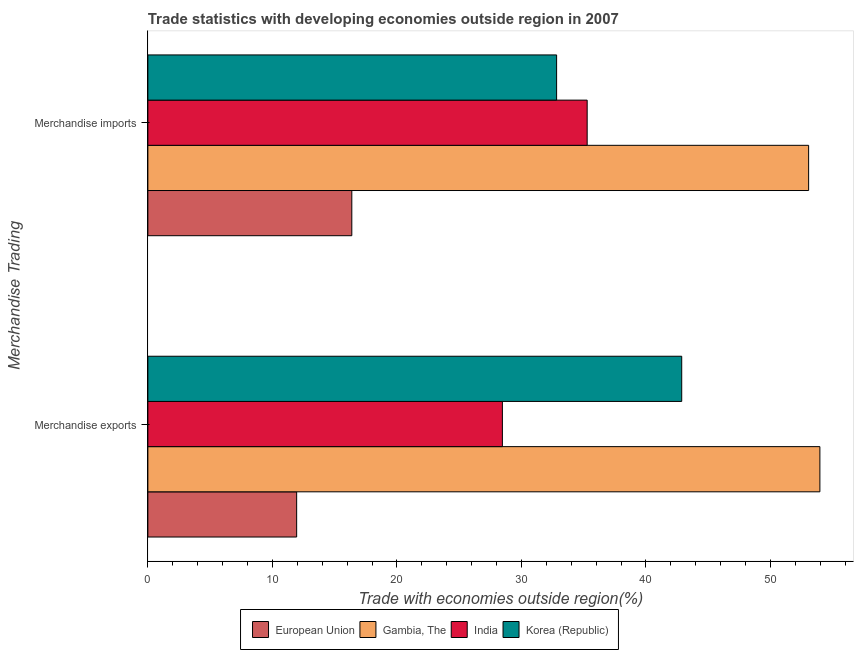How many groups of bars are there?
Offer a terse response. 2. How many bars are there on the 2nd tick from the top?
Provide a short and direct response. 4. How many bars are there on the 1st tick from the bottom?
Offer a terse response. 4. What is the label of the 1st group of bars from the top?
Your answer should be compact. Merchandise imports. What is the merchandise exports in European Union?
Provide a short and direct response. 11.95. Across all countries, what is the maximum merchandise exports?
Keep it short and to the point. 53.97. Across all countries, what is the minimum merchandise imports?
Provide a succinct answer. 16.38. In which country was the merchandise imports maximum?
Ensure brevity in your answer.  Gambia, The. In which country was the merchandise exports minimum?
Ensure brevity in your answer.  European Union. What is the total merchandise exports in the graph?
Your answer should be compact. 137.26. What is the difference between the merchandise exports in European Union and that in India?
Make the answer very short. -16.52. What is the difference between the merchandise exports in India and the merchandise imports in Gambia, The?
Make the answer very short. -24.59. What is the average merchandise imports per country?
Provide a short and direct response. 34.39. What is the difference between the merchandise imports and merchandise exports in Gambia, The?
Offer a very short reply. -0.9. What is the ratio of the merchandise exports in India to that in Korea (Republic)?
Offer a terse response. 0.66. In how many countries, is the merchandise imports greater than the average merchandise imports taken over all countries?
Keep it short and to the point. 2. What does the 3rd bar from the top in Merchandise imports represents?
Make the answer very short. Gambia, The. How many bars are there?
Ensure brevity in your answer.  8. Are all the bars in the graph horizontal?
Keep it short and to the point. Yes. What is the difference between two consecutive major ticks on the X-axis?
Give a very brief answer. 10. Does the graph contain any zero values?
Keep it short and to the point. No. Where does the legend appear in the graph?
Keep it short and to the point. Bottom center. What is the title of the graph?
Keep it short and to the point. Trade statistics with developing economies outside region in 2007. Does "Benin" appear as one of the legend labels in the graph?
Your answer should be compact. No. What is the label or title of the X-axis?
Make the answer very short. Trade with economies outside region(%). What is the label or title of the Y-axis?
Your answer should be very brief. Merchandise Trading. What is the Trade with economies outside region(%) of European Union in Merchandise exports?
Make the answer very short. 11.95. What is the Trade with economies outside region(%) of Gambia, The in Merchandise exports?
Ensure brevity in your answer.  53.97. What is the Trade with economies outside region(%) of India in Merchandise exports?
Provide a succinct answer. 28.47. What is the Trade with economies outside region(%) of Korea (Republic) in Merchandise exports?
Ensure brevity in your answer.  42.87. What is the Trade with economies outside region(%) in European Union in Merchandise imports?
Make the answer very short. 16.38. What is the Trade with economies outside region(%) in Gambia, The in Merchandise imports?
Your answer should be very brief. 53.06. What is the Trade with economies outside region(%) of India in Merchandise imports?
Keep it short and to the point. 35.28. What is the Trade with economies outside region(%) of Korea (Republic) in Merchandise imports?
Provide a short and direct response. 32.83. Across all Merchandise Trading, what is the maximum Trade with economies outside region(%) in European Union?
Offer a very short reply. 16.38. Across all Merchandise Trading, what is the maximum Trade with economies outside region(%) in Gambia, The?
Provide a succinct answer. 53.97. Across all Merchandise Trading, what is the maximum Trade with economies outside region(%) of India?
Give a very brief answer. 35.28. Across all Merchandise Trading, what is the maximum Trade with economies outside region(%) in Korea (Republic)?
Keep it short and to the point. 42.87. Across all Merchandise Trading, what is the minimum Trade with economies outside region(%) in European Union?
Ensure brevity in your answer.  11.95. Across all Merchandise Trading, what is the minimum Trade with economies outside region(%) of Gambia, The?
Keep it short and to the point. 53.06. Across all Merchandise Trading, what is the minimum Trade with economies outside region(%) in India?
Your answer should be very brief. 28.47. Across all Merchandise Trading, what is the minimum Trade with economies outside region(%) in Korea (Republic)?
Keep it short and to the point. 32.83. What is the total Trade with economies outside region(%) in European Union in the graph?
Keep it short and to the point. 28.33. What is the total Trade with economies outside region(%) in Gambia, The in the graph?
Your response must be concise. 107.03. What is the total Trade with economies outside region(%) in India in the graph?
Provide a succinct answer. 63.75. What is the total Trade with economies outside region(%) of Korea (Republic) in the graph?
Give a very brief answer. 75.7. What is the difference between the Trade with economies outside region(%) in European Union in Merchandise exports and that in Merchandise imports?
Provide a succinct answer. -4.43. What is the difference between the Trade with economies outside region(%) in Gambia, The in Merchandise exports and that in Merchandise imports?
Offer a terse response. 0.9. What is the difference between the Trade with economies outside region(%) of India in Merchandise exports and that in Merchandise imports?
Your response must be concise. -6.81. What is the difference between the Trade with economies outside region(%) in Korea (Republic) in Merchandise exports and that in Merchandise imports?
Keep it short and to the point. 10.05. What is the difference between the Trade with economies outside region(%) of European Union in Merchandise exports and the Trade with economies outside region(%) of Gambia, The in Merchandise imports?
Your answer should be compact. -41.12. What is the difference between the Trade with economies outside region(%) of European Union in Merchandise exports and the Trade with economies outside region(%) of India in Merchandise imports?
Offer a terse response. -23.33. What is the difference between the Trade with economies outside region(%) of European Union in Merchandise exports and the Trade with economies outside region(%) of Korea (Republic) in Merchandise imports?
Your response must be concise. -20.88. What is the difference between the Trade with economies outside region(%) in Gambia, The in Merchandise exports and the Trade with economies outside region(%) in India in Merchandise imports?
Your response must be concise. 18.69. What is the difference between the Trade with economies outside region(%) in Gambia, The in Merchandise exports and the Trade with economies outside region(%) in Korea (Republic) in Merchandise imports?
Keep it short and to the point. 21.14. What is the difference between the Trade with economies outside region(%) of India in Merchandise exports and the Trade with economies outside region(%) of Korea (Republic) in Merchandise imports?
Ensure brevity in your answer.  -4.35. What is the average Trade with economies outside region(%) of European Union per Merchandise Trading?
Keep it short and to the point. 14.16. What is the average Trade with economies outside region(%) of Gambia, The per Merchandise Trading?
Provide a succinct answer. 53.52. What is the average Trade with economies outside region(%) of India per Merchandise Trading?
Your answer should be very brief. 31.88. What is the average Trade with economies outside region(%) of Korea (Republic) per Merchandise Trading?
Your answer should be compact. 37.85. What is the difference between the Trade with economies outside region(%) in European Union and Trade with economies outside region(%) in Gambia, The in Merchandise exports?
Offer a terse response. -42.02. What is the difference between the Trade with economies outside region(%) in European Union and Trade with economies outside region(%) in India in Merchandise exports?
Your response must be concise. -16.52. What is the difference between the Trade with economies outside region(%) in European Union and Trade with economies outside region(%) in Korea (Republic) in Merchandise exports?
Make the answer very short. -30.92. What is the difference between the Trade with economies outside region(%) of Gambia, The and Trade with economies outside region(%) of India in Merchandise exports?
Keep it short and to the point. 25.5. What is the difference between the Trade with economies outside region(%) in Gambia, The and Trade with economies outside region(%) in Korea (Republic) in Merchandise exports?
Provide a short and direct response. 11.1. What is the difference between the Trade with economies outside region(%) of India and Trade with economies outside region(%) of Korea (Republic) in Merchandise exports?
Make the answer very short. -14.4. What is the difference between the Trade with economies outside region(%) in European Union and Trade with economies outside region(%) in Gambia, The in Merchandise imports?
Your answer should be compact. -36.69. What is the difference between the Trade with economies outside region(%) in European Union and Trade with economies outside region(%) in India in Merchandise imports?
Offer a terse response. -18.9. What is the difference between the Trade with economies outside region(%) in European Union and Trade with economies outside region(%) in Korea (Republic) in Merchandise imports?
Offer a terse response. -16.45. What is the difference between the Trade with economies outside region(%) in Gambia, The and Trade with economies outside region(%) in India in Merchandise imports?
Provide a succinct answer. 17.78. What is the difference between the Trade with economies outside region(%) of Gambia, The and Trade with economies outside region(%) of Korea (Republic) in Merchandise imports?
Offer a very short reply. 20.24. What is the difference between the Trade with economies outside region(%) in India and Trade with economies outside region(%) in Korea (Republic) in Merchandise imports?
Ensure brevity in your answer.  2.45. What is the ratio of the Trade with economies outside region(%) of European Union in Merchandise exports to that in Merchandise imports?
Ensure brevity in your answer.  0.73. What is the ratio of the Trade with economies outside region(%) in Gambia, The in Merchandise exports to that in Merchandise imports?
Provide a short and direct response. 1.02. What is the ratio of the Trade with economies outside region(%) in India in Merchandise exports to that in Merchandise imports?
Ensure brevity in your answer.  0.81. What is the ratio of the Trade with economies outside region(%) in Korea (Republic) in Merchandise exports to that in Merchandise imports?
Offer a very short reply. 1.31. What is the difference between the highest and the second highest Trade with economies outside region(%) in European Union?
Your answer should be very brief. 4.43. What is the difference between the highest and the second highest Trade with economies outside region(%) in Gambia, The?
Provide a short and direct response. 0.9. What is the difference between the highest and the second highest Trade with economies outside region(%) in India?
Make the answer very short. 6.81. What is the difference between the highest and the second highest Trade with economies outside region(%) of Korea (Republic)?
Your response must be concise. 10.05. What is the difference between the highest and the lowest Trade with economies outside region(%) in European Union?
Ensure brevity in your answer.  4.43. What is the difference between the highest and the lowest Trade with economies outside region(%) in Gambia, The?
Provide a short and direct response. 0.9. What is the difference between the highest and the lowest Trade with economies outside region(%) in India?
Keep it short and to the point. 6.81. What is the difference between the highest and the lowest Trade with economies outside region(%) of Korea (Republic)?
Ensure brevity in your answer.  10.05. 